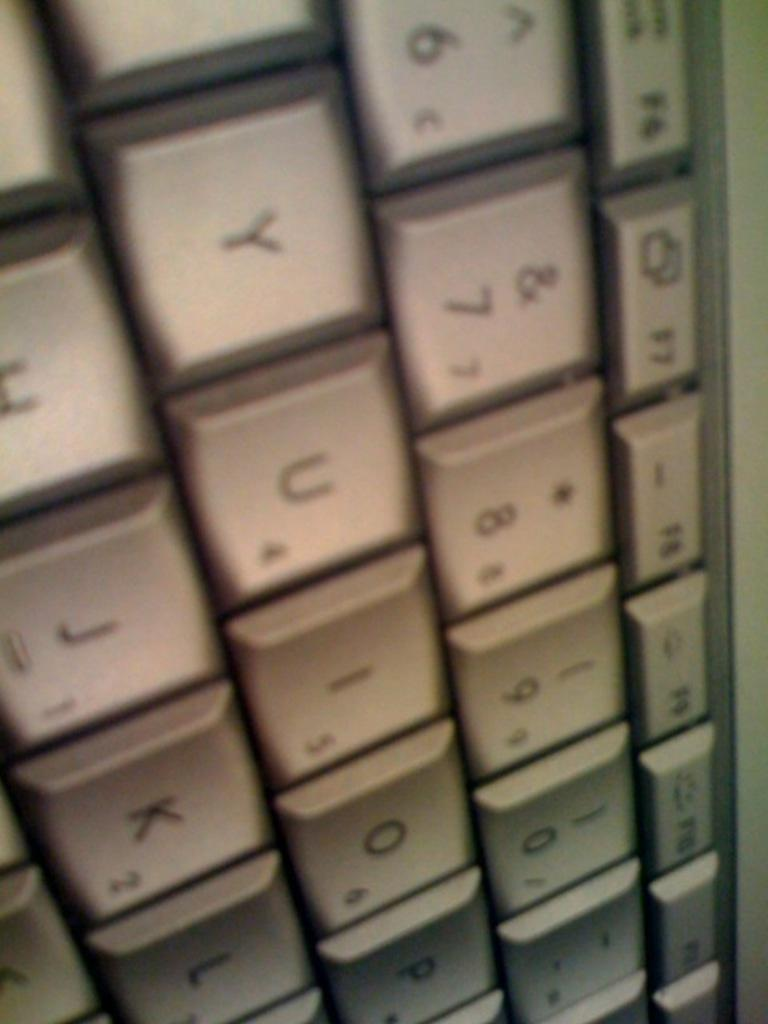Provide a one-sentence caption for the provided image. A section of a computer keyboard showing several letters and numbers 6 through 9 as well as 0. 